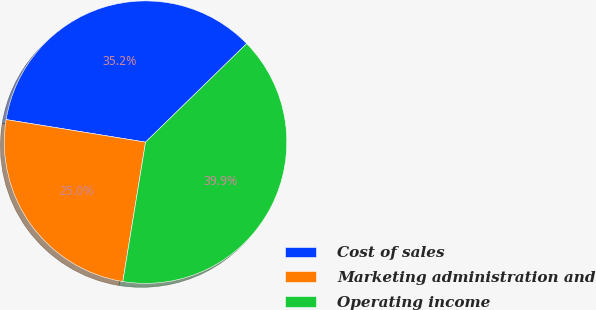<chart> <loc_0><loc_0><loc_500><loc_500><pie_chart><fcel>Cost of sales<fcel>Marketing administration and<fcel>Operating income<nl><fcel>35.15%<fcel>24.98%<fcel>39.87%<nl></chart> 